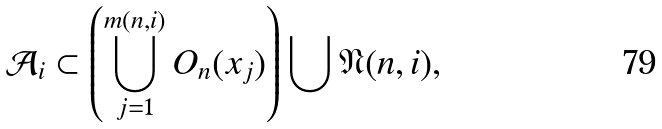<formula> <loc_0><loc_0><loc_500><loc_500>\mathcal { A } _ { i } \subset \left ( \bigcup _ { j = 1 } ^ { m ( n , i ) } O _ { n } ( x _ { j } ) \right ) \bigcup \mathfrak { N } ( n , i ) ,</formula> 